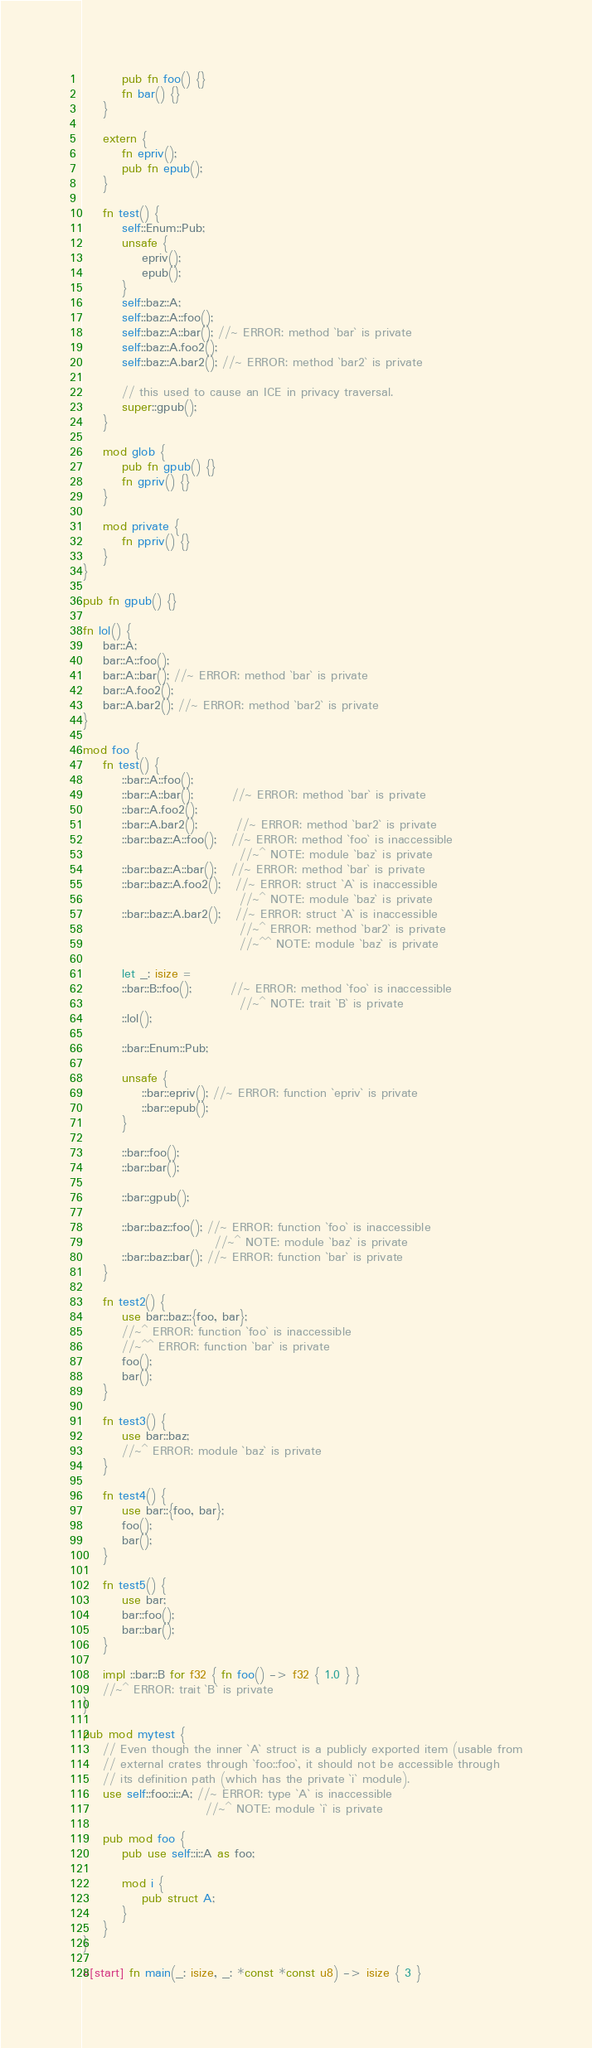Convert code to text. <code><loc_0><loc_0><loc_500><loc_500><_Rust_>        pub fn foo() {}
        fn bar() {}
    }

    extern {
        fn epriv();
        pub fn epub();
    }

    fn test() {
        self::Enum::Pub;
        unsafe {
            epriv();
            epub();
        }
        self::baz::A;
        self::baz::A::foo();
        self::baz::A::bar(); //~ ERROR: method `bar` is private
        self::baz::A.foo2();
        self::baz::A.bar2(); //~ ERROR: method `bar2` is private

        // this used to cause an ICE in privacy traversal.
        super::gpub();
    }

    mod glob {
        pub fn gpub() {}
        fn gpriv() {}
    }

    mod private {
        fn ppriv() {}
    }
}

pub fn gpub() {}

fn lol() {
    bar::A;
    bar::A::foo();
    bar::A::bar(); //~ ERROR: method `bar` is private
    bar::A.foo2();
    bar::A.bar2(); //~ ERROR: method `bar2` is private
}

mod foo {
    fn test() {
        ::bar::A::foo();
        ::bar::A::bar();        //~ ERROR: method `bar` is private
        ::bar::A.foo2();
        ::bar::A.bar2();        //~ ERROR: method `bar2` is private
        ::bar::baz::A::foo();   //~ ERROR: method `foo` is inaccessible
                                //~^ NOTE: module `baz` is private
        ::bar::baz::A::bar();   //~ ERROR: method `bar` is private
        ::bar::baz::A.foo2();   //~ ERROR: struct `A` is inaccessible
                                //~^ NOTE: module `baz` is private
        ::bar::baz::A.bar2();   //~ ERROR: struct `A` is inaccessible
                                //~^ ERROR: method `bar2` is private
                                //~^^ NOTE: module `baz` is private

        let _: isize =
        ::bar::B::foo();        //~ ERROR: method `foo` is inaccessible
                                //~^ NOTE: trait `B` is private
        ::lol();

        ::bar::Enum::Pub;

        unsafe {
            ::bar::epriv(); //~ ERROR: function `epriv` is private
            ::bar::epub();
        }

        ::bar::foo();
        ::bar::bar();

        ::bar::gpub();

        ::bar::baz::foo(); //~ ERROR: function `foo` is inaccessible
                           //~^ NOTE: module `baz` is private
        ::bar::baz::bar(); //~ ERROR: function `bar` is private
    }

    fn test2() {
        use bar::baz::{foo, bar};
        //~^ ERROR: function `foo` is inaccessible
        //~^^ ERROR: function `bar` is private
        foo();
        bar();
    }

    fn test3() {
        use bar::baz;
        //~^ ERROR: module `baz` is private
    }

    fn test4() {
        use bar::{foo, bar};
        foo();
        bar();
    }

    fn test5() {
        use bar;
        bar::foo();
        bar::bar();
    }

    impl ::bar::B for f32 { fn foo() -> f32 { 1.0 } }
    //~^ ERROR: trait `B` is private
}

pub mod mytest {
    // Even though the inner `A` struct is a publicly exported item (usable from
    // external crates through `foo::foo`, it should not be accessible through
    // its definition path (which has the private `i` module).
    use self::foo::i::A; //~ ERROR: type `A` is inaccessible
                         //~^ NOTE: module `i` is private

    pub mod foo {
        pub use self::i::A as foo;

        mod i {
            pub struct A;
        }
    }
}

#[start] fn main(_: isize, _: *const *const u8) -> isize { 3 }
</code> 